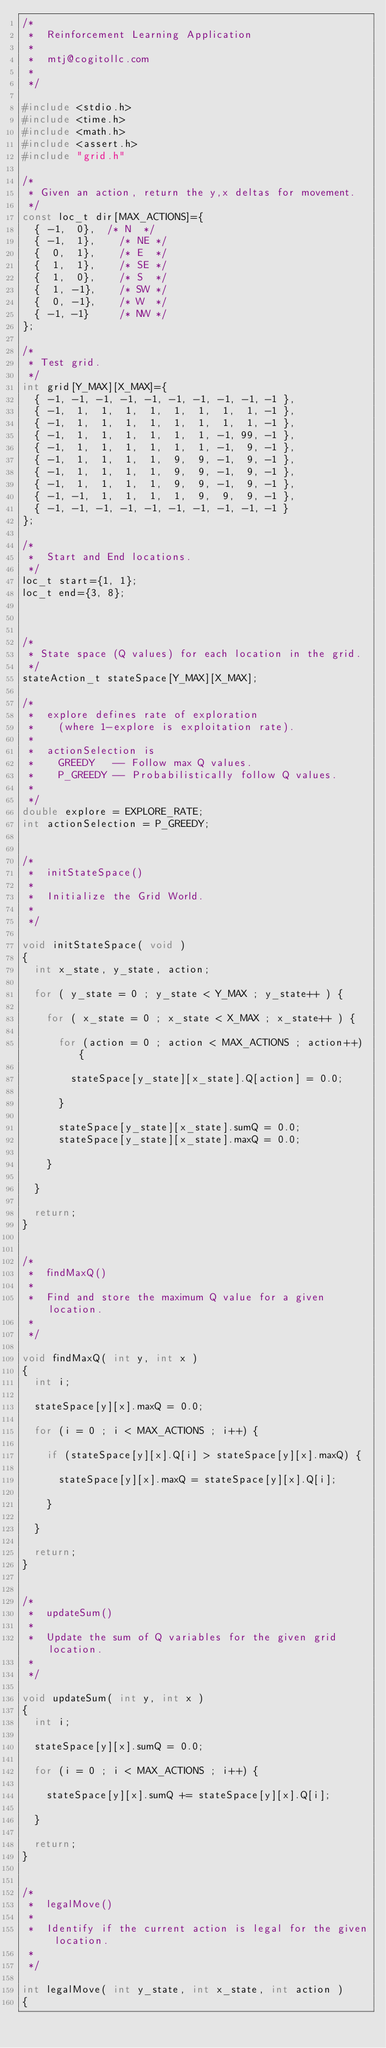<code> <loc_0><loc_0><loc_500><loc_500><_C_>/*
 *  Reinforcement Learning Application
 *
 *  mtj@cogitollc.com
 *
 */

#include <stdio.h>
#include <time.h>
#include <math.h>
#include <assert.h>
#include "grid.h"

/*
 * Given an action, return the y,x deltas for movement.
 */
const loc_t dir[MAX_ACTIONS]={
  { -1,  0},	/* N  */
  { -1,  1},    /* NE */
  {  0,  1},    /* E  */
  {  1,  1},    /* SE */
  {  1,  0},    /* S  */
  {  1, -1},    /* SW */
  {  0, -1},    /* W  */
  { -1, -1}     /* NW */
};

/*
 * Test grid.
 */
int grid[Y_MAX][X_MAX]={
  { -1, -1, -1, -1, -1, -1, -1, -1, -1, -1 },
  { -1,  1,  1,  1,  1,  1,  1,  1,  1, -1 },
  { -1,  1,  1,  1,  1,  1,  1,  1,  1, -1 },
  { -1,  1,  1,  1,  1,  1,  1, -1, 99, -1 },
  { -1,  1,  1,  1,  1,  1,  1, -1,  9, -1 },
  { -1,  1,  1,  1,  1,  9,  9, -1,  9, -1 },
  { -1,  1,  1,  1,  1,  9,  9, -1,  9, -1 },
  { -1,  1,  1,  1,  1,  9,  9, -1,  9, -1 },
  { -1, -1,  1,  1,  1,  1,  9,  9,  9, -1 },
  { -1, -1, -1, -1, -1, -1, -1, -1, -1, -1 }
};

/*
 *  Start and End locations.
 */
loc_t start={1, 1};
loc_t end={3, 8};



/*
 * State space (Q values) for each location in the grid.
 */
stateAction_t stateSpace[Y_MAX][X_MAX];

/*
 *  explore defines rate of exploration
 *    (where 1-explore is exploitation rate).
 *
 *  actionSelection is
 *    GREEDY   -- Follow max Q values.
 *    P_GREEDY -- Probabilistically follow Q values.
 *
 */
double explore = EXPLORE_RATE;
int actionSelection = P_GREEDY;


/*
 *  initStateSpace()
 *
 *  Initialize the Grid World.
 *
 */

void initStateSpace( void )
{
  int x_state, y_state, action;

  for ( y_state = 0 ; y_state < Y_MAX ; y_state++ ) {

    for ( x_state = 0 ; x_state < X_MAX ; x_state++ ) {

      for (action = 0 ; action < MAX_ACTIONS ; action++) {

        stateSpace[y_state][x_state].Q[action] = 0.0;

      }

      stateSpace[y_state][x_state].sumQ = 0.0;
      stateSpace[y_state][x_state].maxQ = 0.0;
    
    }

  }

  return;
}


/*
 *  findMaxQ()
 *
 *  Find and store the maximum Q value for a given location.
 *
 */

void findMaxQ( int y, int x )
{
  int i;

  stateSpace[y][x].maxQ = 0.0;

  for (i = 0 ; i < MAX_ACTIONS ; i++) {

    if (stateSpace[y][x].Q[i] > stateSpace[y][x].maxQ) {

      stateSpace[y][x].maxQ = stateSpace[y][x].Q[i];

    }

  }

  return;
}


/*
 *  updateSum()
 *
 *  Update the sum of Q variables for the given grid location.
 *
 */

void updateSum( int y, int x )
{
  int i;

  stateSpace[y][x].sumQ = 0.0;

  for (i = 0 ; i < MAX_ACTIONS ; i++) {

    stateSpace[y][x].sumQ += stateSpace[y][x].Q[i];

  }

  return;
}


/*
 *  legalMove()
 *
 *  Identify if the current action is legal for the given location.
 *
 */

int legalMove( int y_state, int x_state, int action )
{</code> 